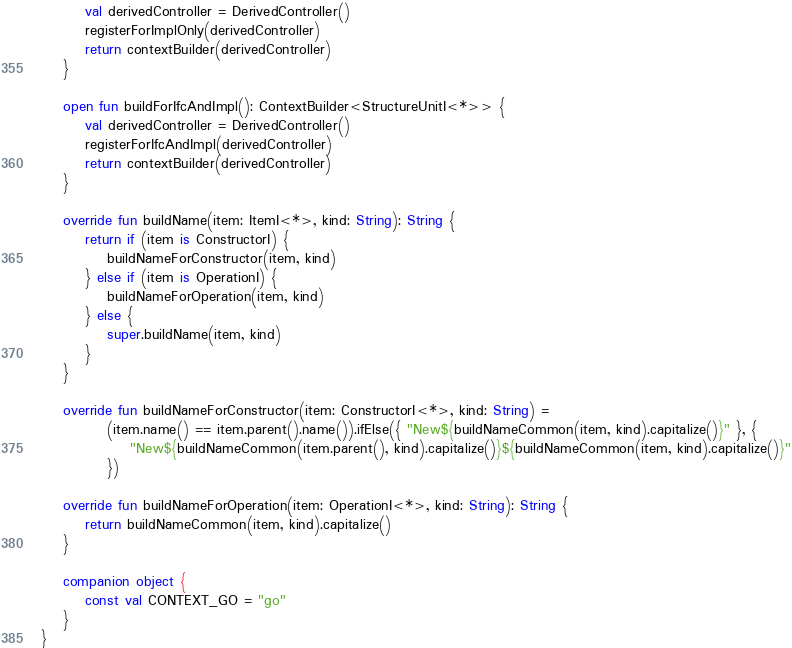<code> <loc_0><loc_0><loc_500><loc_500><_Kotlin_>        val derivedController = DerivedController()
        registerForImplOnly(derivedController)
        return contextBuilder(derivedController)
    }

    open fun buildForIfcAndImpl(): ContextBuilder<StructureUnitI<*>> {
        val derivedController = DerivedController()
        registerForIfcAndImpl(derivedController)
        return contextBuilder(derivedController)
    }

    override fun buildName(item: ItemI<*>, kind: String): String {
        return if (item is ConstructorI) {
            buildNameForConstructor(item, kind)
        } else if (item is OperationI) {
            buildNameForOperation(item, kind)
        } else {
            super.buildName(item, kind)
        }
    }

    override fun buildNameForConstructor(item: ConstructorI<*>, kind: String) =
            (item.name() == item.parent().name()).ifElse({ "New${buildNameCommon(item, kind).capitalize()}" }, {
                "New${buildNameCommon(item.parent(), kind).capitalize()}${buildNameCommon(item, kind).capitalize()}"
            })

    override fun buildNameForOperation(item: OperationI<*>, kind: String): String {
        return buildNameCommon(item, kind).capitalize()
    }

    companion object {
        const val CONTEXT_GO = "go"
    }
}</code> 